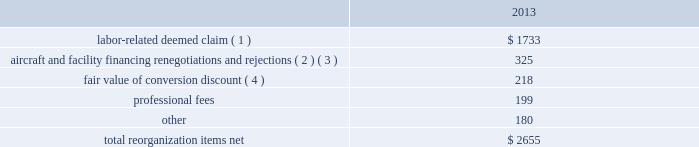Table of contents extinguishment costs incurred as a result of the repayment of certain aircraft secured indebtedness , including cash interest charges and non-cash write offs of unamortized debt issuance costs .
As a result of the 2013 refinancing activities and the early extinguishment of american 2019s 7.50% ( 7.50 % ) senior secured notes in 2014 , we recognized $ 100 million less interest expense in 2014 as compared to the 2013 period .
Other nonoperating expense , net in 2014 consisted principally of net foreign currency losses of $ 114 million and early debt extinguishment charges of $ 56 million .
Other nonoperating expense , net in 2013 consisted principally of net foreign currency losses of $ 56 million and early debt extinguishment charges of $ 29 million .
Other nonoperating expense , net increased $ 64 million , or 73.1% ( 73.1 % ) , during 2014 primarily due to special charges recognized as a result of early debt extinguishment and an increase in foreign currency losses driven by the strengthening of the u.s .
Dollar in foreign currency transactions , principally in latin american markets .
We recorded a $ 43 million special charge for venezuelan foreign currency losses in 2014 .
See part ii , item 7a .
Quantitative and qualitative disclosures about market risk for further discussion of our cash held in venezuelan bolivars .
In addition , our 2014 nonoperating special items included $ 56 million primarily related to the early extinguishment of american 2019s 7.50% ( 7.50 % ) senior secured notes and other indebtedness .
Reorganization items , net reorganization items refer to revenues , expenses ( including professional fees ) , realized gains and losses and provisions for losses that are realized or incurred as a direct result of the chapter 11 cases .
The table summarizes the components included in reorganization items , net on aag 2019s consolidated statement of operations for the year ended december 31 , 2013 ( in millions ) : .
( 1 ) in exchange for employees 2019 contributions to the successful reorganization , including agreeing to reductions in pay and benefits , we agreed in the plan to provide each employee group a deemed claim , which was used to provide a distribution of a portion of the equity of the reorganized entity to those employees .
Each employee group received a deemed claim amount based upon a portion of the value of cost savings provided by that group through reductions to pay and benefits as well as through certain work rule changes .
The total value of this deemed claim was approximately $ 1.7 billion .
( 2 ) amounts include allowed claims ( claims approved by the bankruptcy court ) and estimated allowed claims relating to ( i ) the rejection or modification of financings related to aircraft and ( ii ) entry of orders treated as unsecured claims with respect to facility agreements supporting certain issuances of special facility revenue bonds .
The debtors recorded an estimated claim associated with the rejection or modification of a financing or facility agreement when the applicable motion was filed with the bankruptcy court to reject or modify such financing or facility agreement and the debtors believed that it was probable the motion would be approved , and there was sufficient information to estimate the claim .
See note 2 to aag 2019s consolidated financial statements in part ii , item 8a for further information .
( 3 ) pursuant to the plan , the debtors agreed to allow certain post-petition unsecured claims on obligations .
As a result , during the year ended december 31 , 2013 , we recorded reorganization charges to adjust estimated allowed claim amounts previously recorded on rejected special facility revenue bonds of $ 180 million , allowed general unsecured claims related to the 1990 and 1994 series of special facility revenue bonds that financed certain improvements at jfk , and rejected bonds that financed certain improvements at ord , which are included in the table above. .
What was the percent of the labor-related deemed claim to the total re-organization costs? 
Rationale: the amount in question divide by the total amount time 100
Computations: (1733 / 2655)
Answer: 0.65273. Table of contents extinguishment costs incurred as a result of the repayment of certain aircraft secured indebtedness , including cash interest charges and non-cash write offs of unamortized debt issuance costs .
As a result of the 2013 refinancing activities and the early extinguishment of american 2019s 7.50% ( 7.50 % ) senior secured notes in 2014 , we recognized $ 100 million less interest expense in 2014 as compared to the 2013 period .
Other nonoperating expense , net in 2014 consisted principally of net foreign currency losses of $ 114 million and early debt extinguishment charges of $ 56 million .
Other nonoperating expense , net in 2013 consisted principally of net foreign currency losses of $ 56 million and early debt extinguishment charges of $ 29 million .
Other nonoperating expense , net increased $ 64 million , or 73.1% ( 73.1 % ) , during 2014 primarily due to special charges recognized as a result of early debt extinguishment and an increase in foreign currency losses driven by the strengthening of the u.s .
Dollar in foreign currency transactions , principally in latin american markets .
We recorded a $ 43 million special charge for venezuelan foreign currency losses in 2014 .
See part ii , item 7a .
Quantitative and qualitative disclosures about market risk for further discussion of our cash held in venezuelan bolivars .
In addition , our 2014 nonoperating special items included $ 56 million primarily related to the early extinguishment of american 2019s 7.50% ( 7.50 % ) senior secured notes and other indebtedness .
Reorganization items , net reorganization items refer to revenues , expenses ( including professional fees ) , realized gains and losses and provisions for losses that are realized or incurred as a direct result of the chapter 11 cases .
The table summarizes the components included in reorganization items , net on aag 2019s consolidated statement of operations for the year ended december 31 , 2013 ( in millions ) : .
( 1 ) in exchange for employees 2019 contributions to the successful reorganization , including agreeing to reductions in pay and benefits , we agreed in the plan to provide each employee group a deemed claim , which was used to provide a distribution of a portion of the equity of the reorganized entity to those employees .
Each employee group received a deemed claim amount based upon a portion of the value of cost savings provided by that group through reductions to pay and benefits as well as through certain work rule changes .
The total value of this deemed claim was approximately $ 1.7 billion .
( 2 ) amounts include allowed claims ( claims approved by the bankruptcy court ) and estimated allowed claims relating to ( i ) the rejection or modification of financings related to aircraft and ( ii ) entry of orders treated as unsecured claims with respect to facility agreements supporting certain issuances of special facility revenue bonds .
The debtors recorded an estimated claim associated with the rejection or modification of a financing or facility agreement when the applicable motion was filed with the bankruptcy court to reject or modify such financing or facility agreement and the debtors believed that it was probable the motion would be approved , and there was sufficient information to estimate the claim .
See note 2 to aag 2019s consolidated financial statements in part ii , item 8a for further information .
( 3 ) pursuant to the plan , the debtors agreed to allow certain post-petition unsecured claims on obligations .
As a result , during the year ended december 31 , 2013 , we recorded reorganization charges to adjust estimated allowed claim amounts previously recorded on rejected special facility revenue bonds of $ 180 million , allowed general unsecured claims related to the 1990 and 1994 series of special facility revenue bonds that financed certain improvements at jfk , and rejected bonds that financed certain improvements at ord , which are included in the table above. .
What percentage of total reorganization items net were labor-related deemed claims in 2013? 
Computations: (1733 / 2655)
Answer: 0.65273. Table of contents extinguishment costs incurred as a result of the repayment of certain aircraft secured indebtedness , including cash interest charges and non-cash write offs of unamortized debt issuance costs .
As a result of the 2013 refinancing activities and the early extinguishment of american 2019s 7.50% ( 7.50 % ) senior secured notes in 2014 , we recognized $ 100 million less interest expense in 2014 as compared to the 2013 period .
Other nonoperating expense , net in 2014 consisted principally of net foreign currency losses of $ 114 million and early debt extinguishment charges of $ 56 million .
Other nonoperating expense , net in 2013 consisted principally of net foreign currency losses of $ 56 million and early debt extinguishment charges of $ 29 million .
Other nonoperating expense , net increased $ 64 million , or 73.1% ( 73.1 % ) , during 2014 primarily due to special charges recognized as a result of early debt extinguishment and an increase in foreign currency losses driven by the strengthening of the u.s .
Dollar in foreign currency transactions , principally in latin american markets .
We recorded a $ 43 million special charge for venezuelan foreign currency losses in 2014 .
See part ii , item 7a .
Quantitative and qualitative disclosures about market risk for further discussion of our cash held in venezuelan bolivars .
In addition , our 2014 nonoperating special items included $ 56 million primarily related to the early extinguishment of american 2019s 7.50% ( 7.50 % ) senior secured notes and other indebtedness .
Reorganization items , net reorganization items refer to revenues , expenses ( including professional fees ) , realized gains and losses and provisions for losses that are realized or incurred as a direct result of the chapter 11 cases .
The table summarizes the components included in reorganization items , net on aag 2019s consolidated statement of operations for the year ended december 31 , 2013 ( in millions ) : .
( 1 ) in exchange for employees 2019 contributions to the successful reorganization , including agreeing to reductions in pay and benefits , we agreed in the plan to provide each employee group a deemed claim , which was used to provide a distribution of a portion of the equity of the reorganized entity to those employees .
Each employee group received a deemed claim amount based upon a portion of the value of cost savings provided by that group through reductions to pay and benefits as well as through certain work rule changes .
The total value of this deemed claim was approximately $ 1.7 billion .
( 2 ) amounts include allowed claims ( claims approved by the bankruptcy court ) and estimated allowed claims relating to ( i ) the rejection or modification of financings related to aircraft and ( ii ) entry of orders treated as unsecured claims with respect to facility agreements supporting certain issuances of special facility revenue bonds .
The debtors recorded an estimated claim associated with the rejection or modification of a financing or facility agreement when the applicable motion was filed with the bankruptcy court to reject or modify such financing or facility agreement and the debtors believed that it was probable the motion would be approved , and there was sufficient information to estimate the claim .
See note 2 to aag 2019s consolidated financial statements in part ii , item 8a for further information .
( 3 ) pursuant to the plan , the debtors agreed to allow certain post-petition unsecured claims on obligations .
As a result , during the year ended december 31 , 2013 , we recorded reorganization charges to adjust estimated allowed claim amounts previously recorded on rejected special facility revenue bonds of $ 180 million , allowed general unsecured claims related to the 1990 and 1994 series of special facility revenue bonds that financed certain improvements at jfk , and rejected bonds that financed certain improvements at ord , which are included in the table above. .
What percentage of total reorganization items net were aircraft and facility financing renegotiations and rejections in 2013? 
Computations: (325 / 2655)
Answer: 0.12241. 